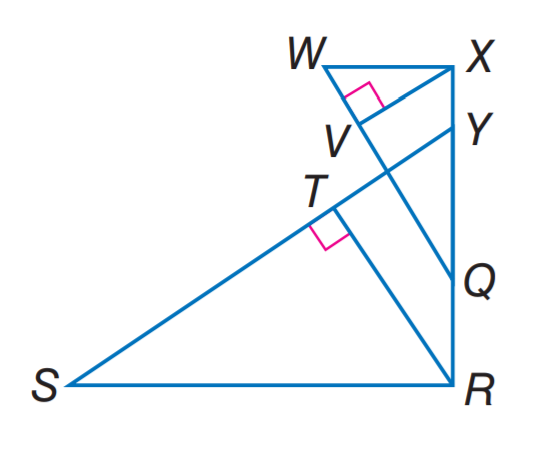Question: If \triangle S R Y \sim \triangle W X Q, R T is an altitude of \triangle S R Y, X V is an altitude of \triangle W X Q, R T = 5, R Q = 4, Q Y = 6, and Y X = 2, find X V.
Choices:
A. 2
B. 4
C. 5
D. 6
Answer with the letter. Answer: B 